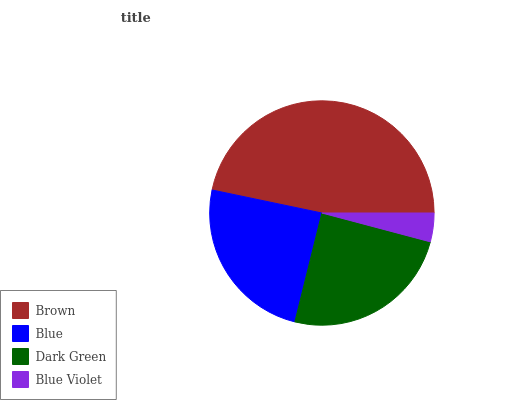Is Blue Violet the minimum?
Answer yes or no. Yes. Is Brown the maximum?
Answer yes or no. Yes. Is Blue the minimum?
Answer yes or no. No. Is Blue the maximum?
Answer yes or no. No. Is Brown greater than Blue?
Answer yes or no. Yes. Is Blue less than Brown?
Answer yes or no. Yes. Is Blue greater than Brown?
Answer yes or no. No. Is Brown less than Blue?
Answer yes or no. No. Is Dark Green the high median?
Answer yes or no. Yes. Is Blue the low median?
Answer yes or no. Yes. Is Blue Violet the high median?
Answer yes or no. No. Is Dark Green the low median?
Answer yes or no. No. 